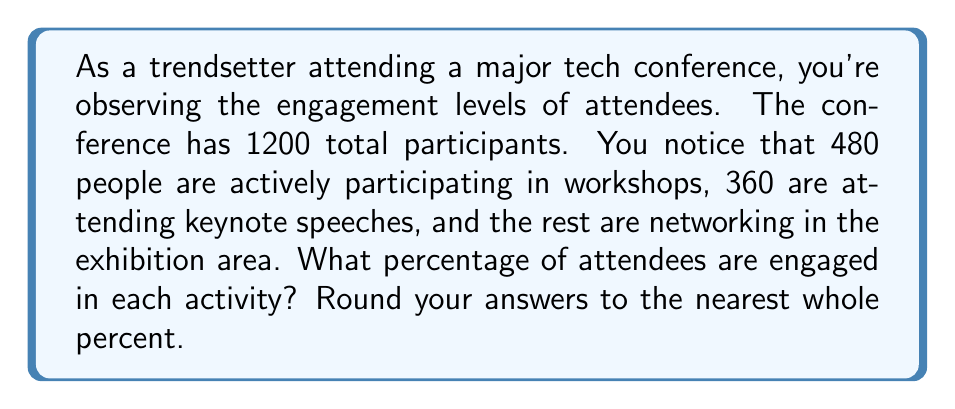Solve this math problem. To solve this problem, we need to:
1. Calculate the number of people networking
2. Find the percentage for each activity

Step 1: Calculate the number of people networking
* Total attendees = 1200
* Attendees in workshops = 480
* Attendees in keynote speeches = 360
* Attendees networking = Total - (Workshops + Keynotes)
$$ 1200 - (480 + 360) = 1200 - 840 = 360 $$

Step 2: Calculate percentages
The formula for percentage is:
$$ \text{Percentage} = \frac{\text{Number in category}}{\text{Total number}} \times 100\% $$

For workshops:
$$ \frac{480}{1200} \times 100\% = 40\% $$

For keynote speeches:
$$ \frac{360}{1200} \times 100\% = 30\% $$

For networking:
$$ \frac{360}{1200} \times 100\% = 30\% $$

Rounding is not necessary as all percentages are already whole numbers.
Answer: Workshops: 40%
Keynote speeches: 30%
Networking: 30% 